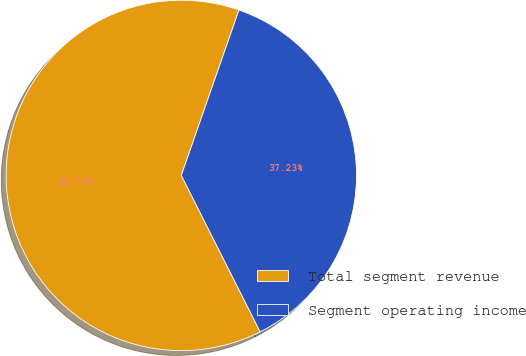Convert chart to OTSL. <chart><loc_0><loc_0><loc_500><loc_500><pie_chart><fcel>Total segment revenue<fcel>Segment operating income<nl><fcel>62.77%<fcel>37.23%<nl></chart> 